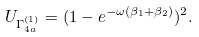<formula> <loc_0><loc_0><loc_500><loc_500>U _ { \Gamma ^ { ( 1 ) } _ { 4 a } } = ( 1 - e ^ { - \omega ( \beta _ { 1 } + \beta _ { 2 } ) } ) ^ { 2 } .</formula> 